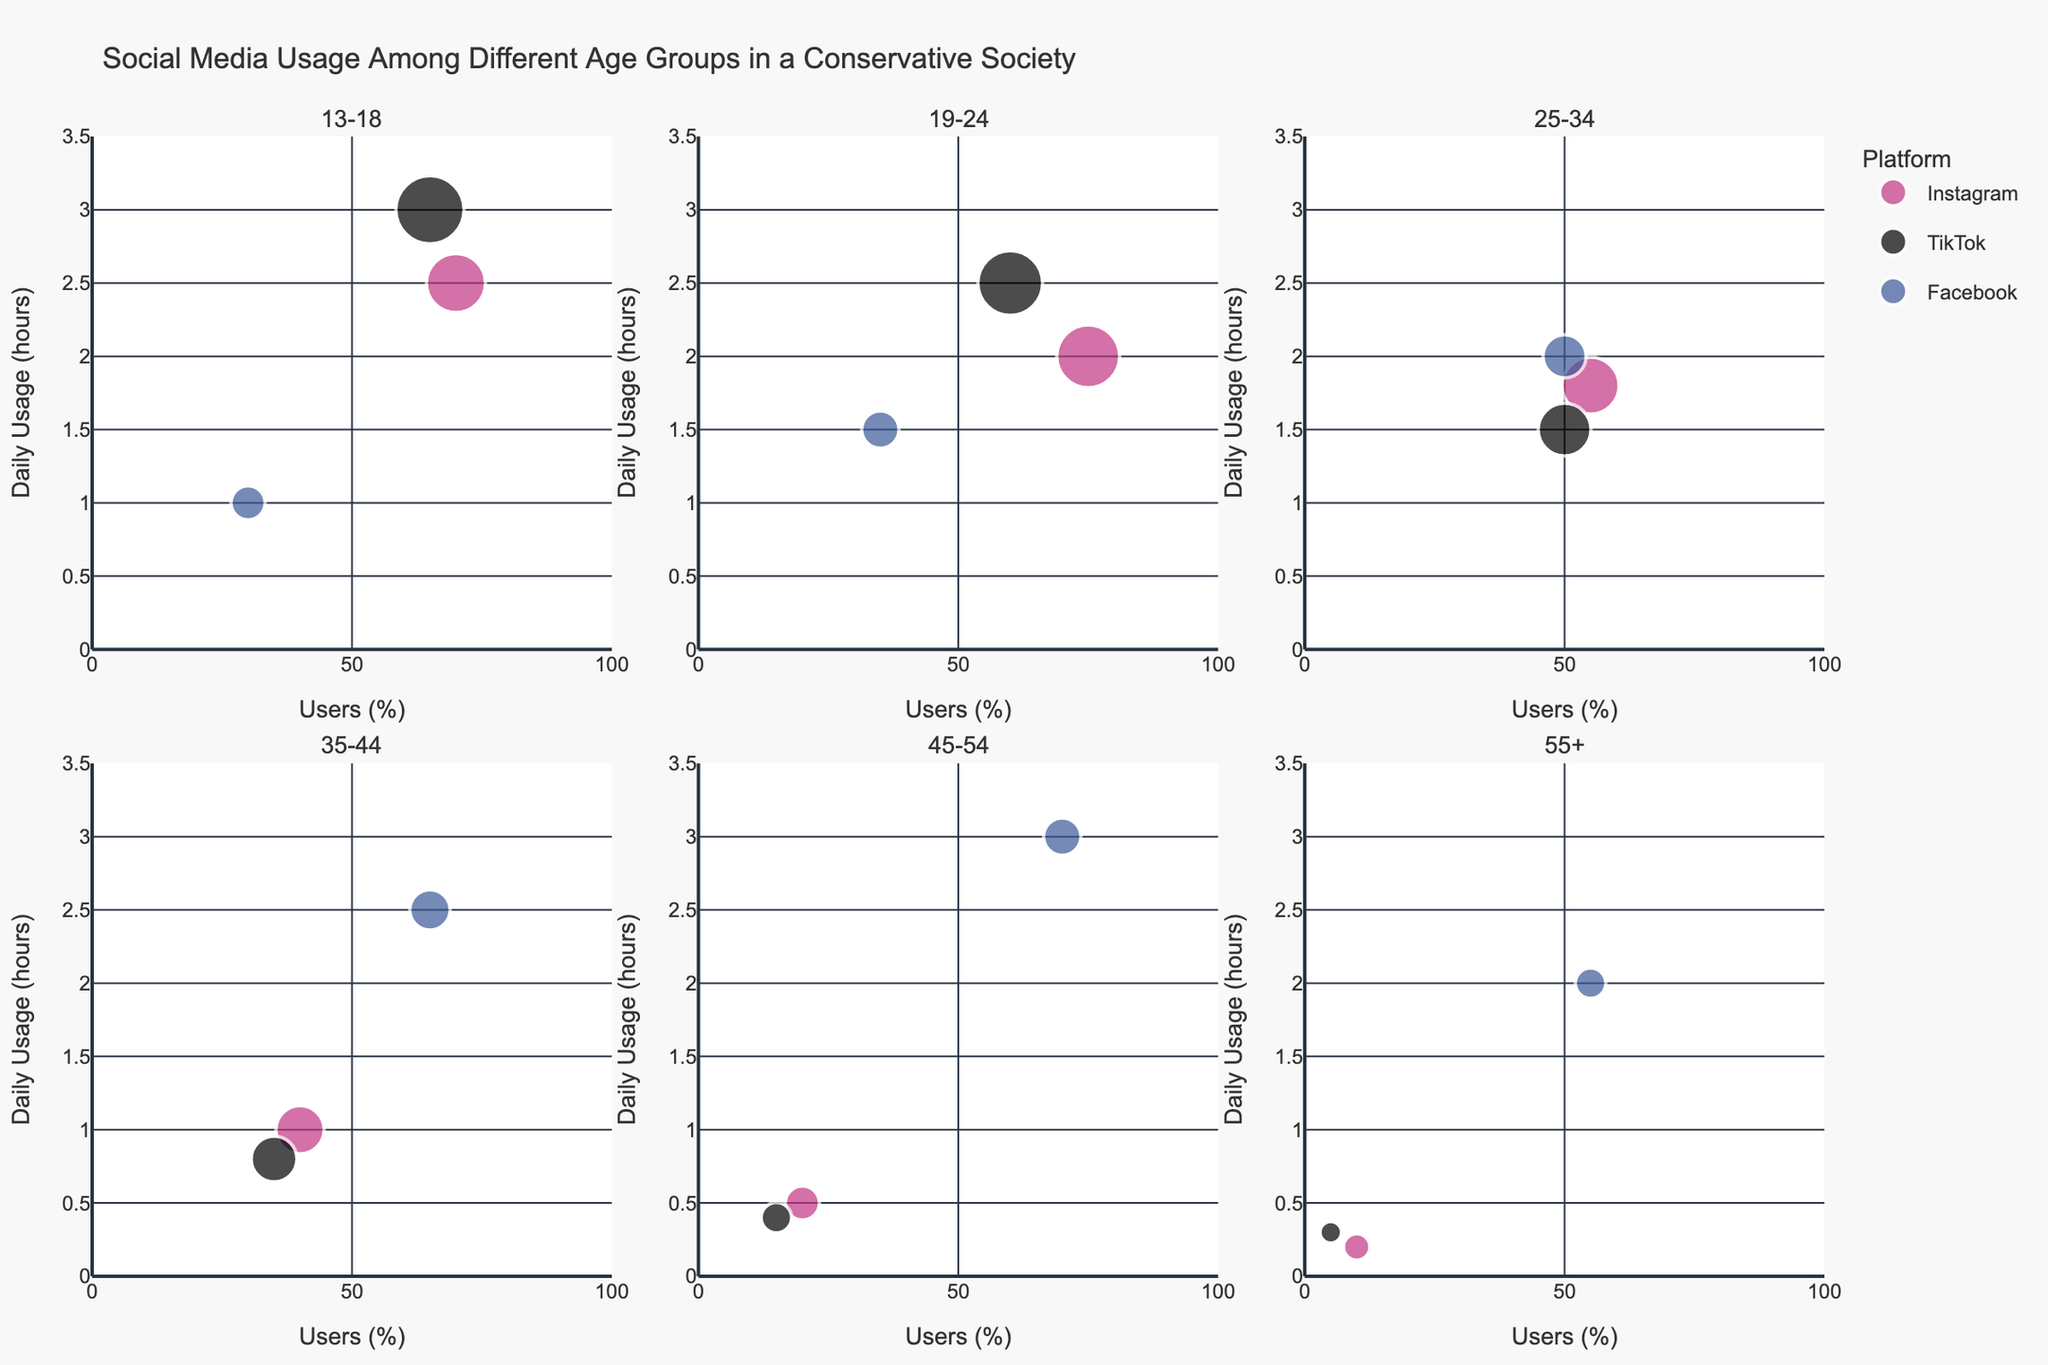What is the title of the figure? The title of the figure is found at the top and summarizes the content.
Answer: Social Media Usage Among Different Age Groups in a Conservative Society Which social media platform has the highest average daily usage for the age group 13-18? In the subplot for the age group 13-18, the bubble positioned at the highest point on the y-axis represents TikTok.
Answer: TikTok How many subplots are there in the figure? The figure is divided into smaller sections for each age group, and there are six unique age groups.
Answer: Six Which platform has the highest engagement among users aged 19-24? Look at the size of bubbles in the subplot for the age group 19-24. The largest bubble, indicating the highest engagement, is for Instagram.
Answer: Instagram What is the range of daily usage hours on the y-axis for each subplot? By examining the y-axis labels for any subplot, the range is from 0 to 3.5 hours.
Answer: 0 to 3.5 hours In the age group 45-54, which platform has the lowest percentage of users? In the age segment 45-54, look at the bubbles closest to the leftmost side of the subplot. TikTok has the lowest percentage of users.
Answer: TikTok How does the average daily usage of Facebook change across age groups? Compare the y-axis positions of the Facebook bubbles across the subplots. It starts lower in younger groups, peaks around age 45-54, then usually decreases for 55+.
Answer: Increases to 45-54, then decreases Which age group has the highest percentage of Instagram users? Look for the Instagram bubble positioned farthest to the right in all subplots. The group 19-24 has the highest percentage.
Answer: 19-24 Compare the average engagement for TikTok users in the age groups 13-18 and 35-44. Which age group has higher engagement? Compare the bubble sizes for TikTok in these two subplots. The bubble is larger in the 13-18 group.
Answer: 13-18 What trend is observed in Instagram's daily usage from the youngest to the oldest age group? Observe the descending y-axis positions of Instagram's bubbles from younger to older subplots, showing a decreasing trend.
Answer: Decreasing trend 